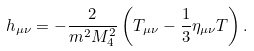Convert formula to latex. <formula><loc_0><loc_0><loc_500><loc_500>h _ { \mu \nu } = - \frac { 2 } { m ^ { 2 } M _ { 4 } ^ { 2 } } \left ( T _ { \mu \nu } - \frac { 1 } { 3 } \eta _ { \mu \nu } T \right ) .</formula> 